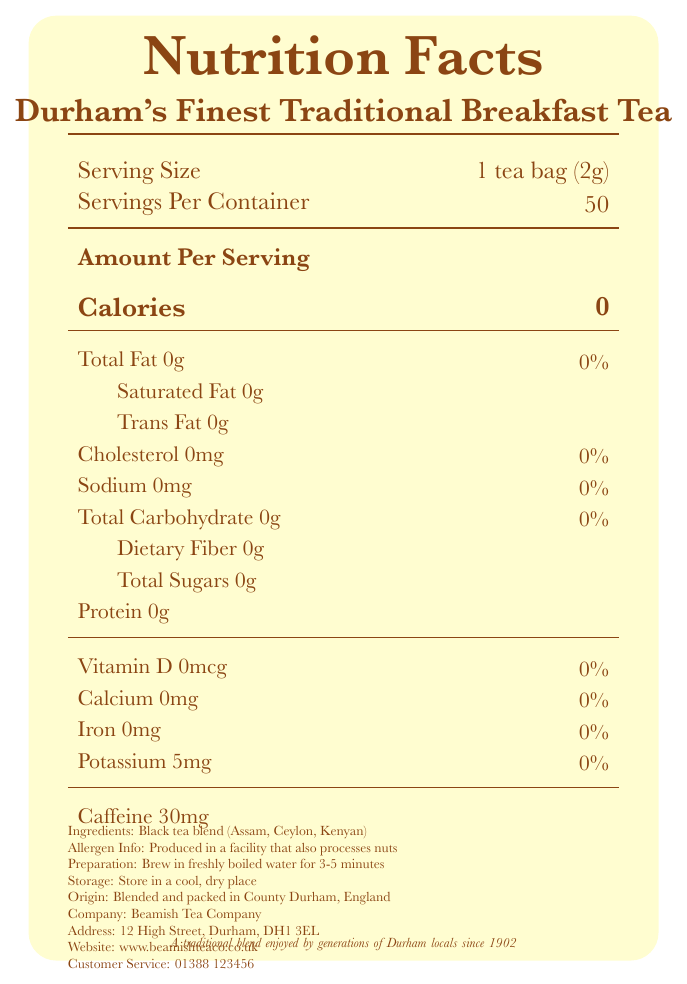what is the serving size? The serving size is explicitly stated as "1 tea bag (2g)" in the document under "Serving Size".
Answer: 1 tea bag (2g) how many calories are in one serving? The number of calories per serving is listed as zero, shown under "Calories".
Answer: 0 which minerals are listed with their amounts in the nutrition facts? Among the listed nutrients, only Potassium is given with an amount, which is 5mg.
Answer: Potassium, 5mg what is the caffeine content per serving? The caffeine content is specified as "Caffeine 30mg" per serving in the document.
Answer: 30mg what are the ingredients of the tea? The ingredients are listed as "Black tea blend (Assam, Ceylon, Kenyan)".
Answer: Black tea blend (Assam, Ceylon, Kenyan) how many servings are there in one container of the tea? The document specifies "Servings Per Container: 50".
Answer: 50 which of the following vitamins or minerals are present in this tea? A. Vitamin C B. Calcium C. Vitamin D D. Potassium The nutrient section lists Potassium with an amount, while Vitamin C, Calcium, and Vitamin D are either zero or not mentioned.
Answer: D. Potassium what is the recommended preparation method for this tea? A. Brew in cold water B. Brew in freshly boiled water for 3-5 minutes C. Microwave for 2 minutes D. Steep for 10 minutes The preparation instructions specify "Brew in freshly boiled water for 3-5 minutes".
Answer: B. Brew in freshly boiled water for 3-5 minutes is there any fat in one serving of this tea? The document states "Total Fat 0g," indicating that there is no fat in a single serving.
Answer: No has this tea been enjoyed by generations of Durham locals? The document states, "A traditional blend enjoyed by generations of Durham locals since 1902".
Answer: Yes why might someone in Durham feel nostalgic about this tea? The additional information section of the document mentions the long-standing tradition and local enjoyment of the tea since 1902.
Answer: The tea blend has been enjoyed by generations of Durham locals since 1902, making it a traditional and familiar product. please summarize the main idea of the document. The summary encompasses the key points of the nutrition facts, ingredients, preparation, and historical significance described in the document.
Answer: The document provides the nutrition facts for Durham's Finest Traditional Breakfast Tea, emphasizing its low-calorie content (0 calories), key ingredients (a black tea blend of Assam, Ceylon, and Kenyan teas), and the preparation method (brew in freshly boiled water for 3-5 minutes). The tea has historical significance, being a traditional blend enjoyed by generations of Durham locals since 1902. what is the contact number for customer service? The customer service contact number is listed as "01388 123456".
Answer: 01388 123456 who produces this tea? The company mentioned in the document is "Beamish Tea Company".
Answer: Beamish Tea Company where should you store the tea to maintain its quality? The storage instructions state "Store in a cool, dry place".
Answer: Store in a cool, dry place how much iron does one serving of the tea contain? The nutrition facts specify that iron content per serving is 0mg.
Answer: 0mg what is the tea's cholesterol content per serving? The document lists the cholesterol content as 0mg per serving.
Answer: 0mg how many grams of protein are in one serving of the tea? According to the nutrition facts, there is 0g of protein per serving.
Answer: 0g how much dietary fiber is in one serving of the tea? The dietary fiber content per serving is listed as 0g.
Answer: 0g what is the physical address of the company? The address of Beamish Tea Company is given as "12 High Street, Durham, DH1 3EL".
Answer: 12 High Street, Durham, DH1 3EL what is the calorie content in two tea bags? The document provides the calorie content per serving size of one tea bag, but does not explicitly state the calorie content for two tea bags. Adjusting for multiple servings without additional context is not detailed in the document.
Answer: Cannot be determined how much total carbohydrate does one serving contain? The nutrition facts list total carbohydrate content as 0g per serving.
Answer: 0g 